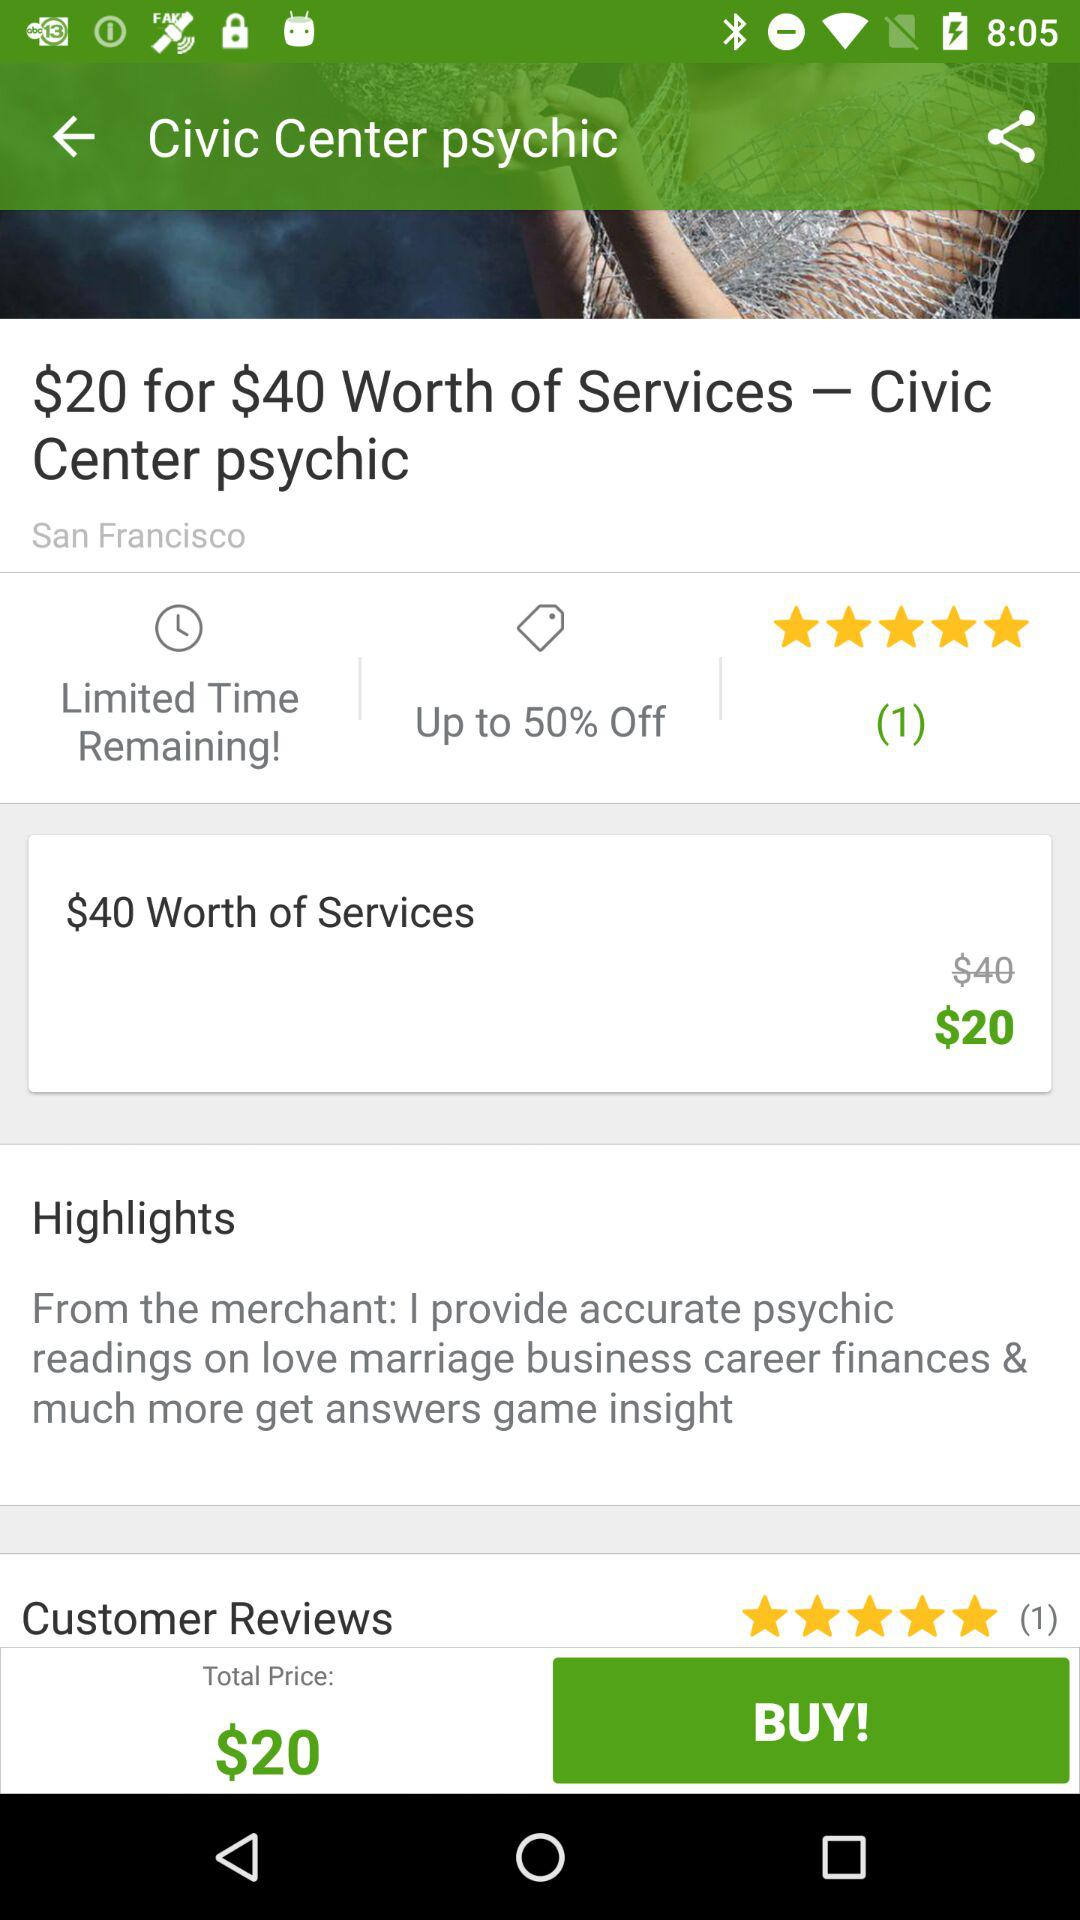Up to how much percentage is off? The discount is up to 50%. 